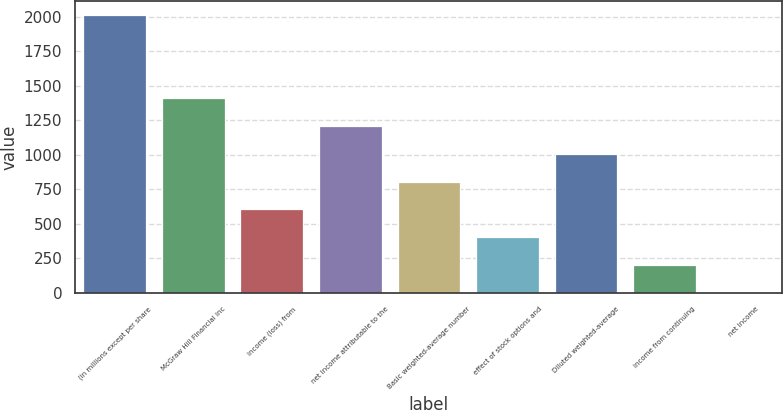<chart> <loc_0><loc_0><loc_500><loc_500><bar_chart><fcel>(in millions except per share<fcel>McGraw Hill Financial inc<fcel>income (loss) from<fcel>net income attributable to the<fcel>Basic weighted-average number<fcel>effect of stock options and<fcel>Diluted weighted-average<fcel>income from continuing<fcel>net income<nl><fcel>2012<fcel>1408.85<fcel>604.69<fcel>1207.81<fcel>805.73<fcel>403.65<fcel>1006.77<fcel>202.61<fcel>1.57<nl></chart> 